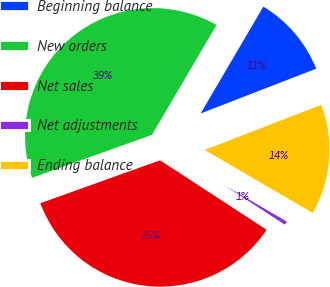Convert chart to OTSL. <chart><loc_0><loc_0><loc_500><loc_500><pie_chart><fcel>Beginning balance<fcel>New orders<fcel>Net sales<fcel>Net adjustments<fcel>Ending balance<nl><fcel>10.67%<fcel>38.93%<fcel>35.32%<fcel>0.8%<fcel>14.28%<nl></chart> 